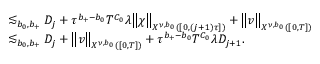<formula> <loc_0><loc_0><loc_500><loc_500>\begin{array} { r l } { \, } & { \lesssim _ { b _ { 0 } , b _ { + } } D _ { j } + \tau ^ { b _ { + } - b _ { 0 } } T ^ { C _ { 0 } } \lambda \left \| \chi \right \| _ { X ^ { \nu , b _ { 0 } } ( [ 0 , ( j + 1 ) \tau ] ) } + \left \| v \right \| _ { X ^ { \nu , b _ { 0 } } ( [ 0 , T ] ) } } \\ & { \lesssim _ { b _ { 0 } , b _ { + } } D _ { j } + \left \| v \right \| _ { X ^ { \nu , b _ { 0 } } ( [ 0 , T ] ) } + \tau ^ { b _ { + } - b _ { 0 } } T ^ { C _ { 0 } } \lambda D _ { j + 1 } . } \end{array}</formula> 